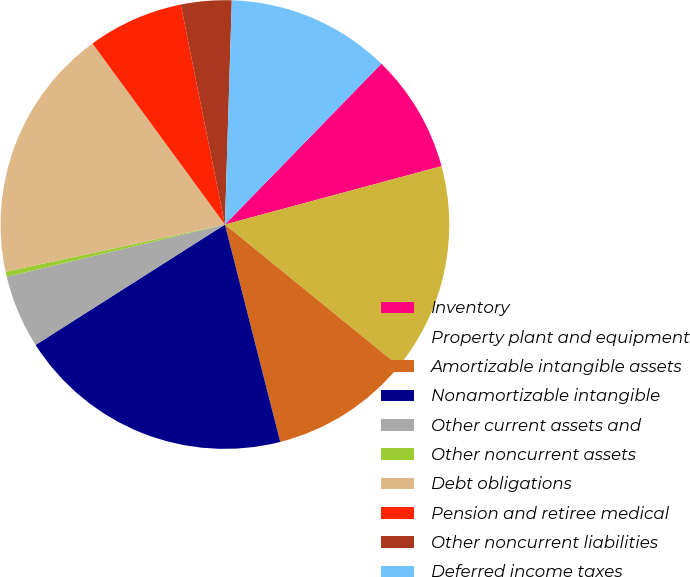Convert chart to OTSL. <chart><loc_0><loc_0><loc_500><loc_500><pie_chart><fcel>Inventory<fcel>Property plant and equipment<fcel>Amortizable intangible assets<fcel>Nonamortizable intangible<fcel>Other current assets and<fcel>Other noncurrent assets<fcel>Debt obligations<fcel>Pension and retiree medical<fcel>Other noncurrent liabilities<fcel>Deferred income taxes<nl><fcel>8.53%<fcel>15.06%<fcel>10.16%<fcel>19.95%<fcel>5.27%<fcel>0.37%<fcel>18.32%<fcel>6.9%<fcel>3.64%<fcel>11.79%<nl></chart> 